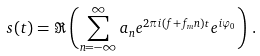<formula> <loc_0><loc_0><loc_500><loc_500>s ( t ) = \Re \left ( \sum _ { n = - \infty } ^ { \infty } a _ { n } e ^ { 2 \pi i ( f + f _ { m } n ) t } e ^ { i \varphi _ { 0 } } \right ) \, .</formula> 